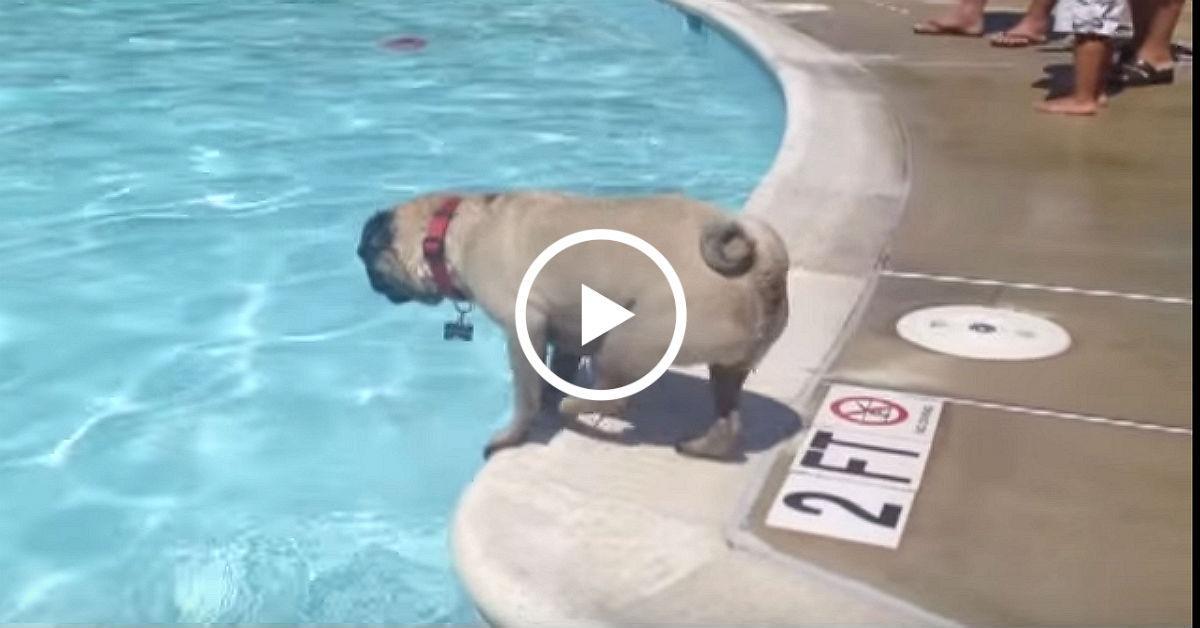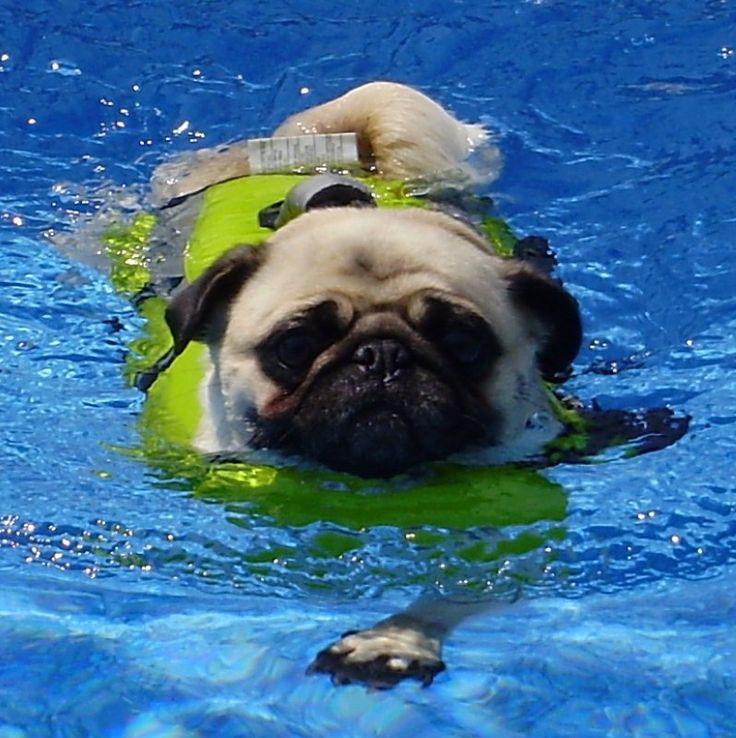The first image is the image on the left, the second image is the image on the right. Given the left and right images, does the statement "There is a pug wearing a life vest." hold true? Answer yes or no. Yes. The first image is the image on the left, the second image is the image on the right. Assess this claim about the two images: "A dog is wearing a life vest.". Correct or not? Answer yes or no. Yes. 